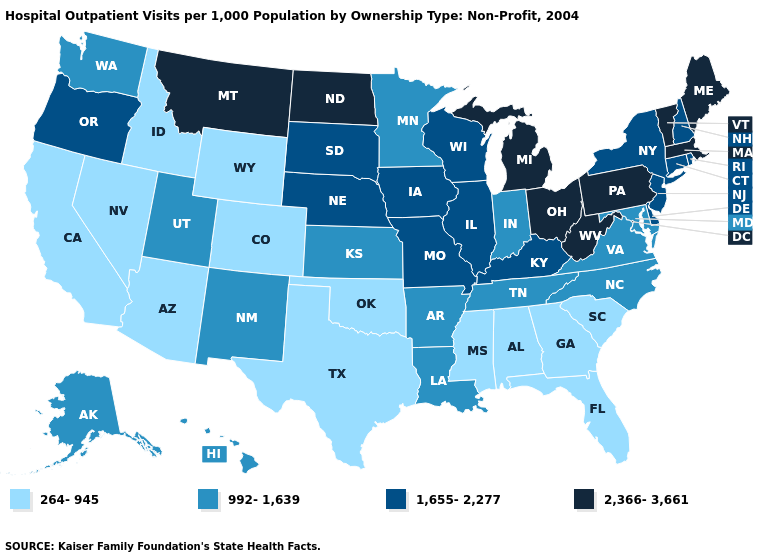Does the map have missing data?
Answer briefly. No. Which states have the highest value in the USA?
Concise answer only. Maine, Massachusetts, Michigan, Montana, North Dakota, Ohio, Pennsylvania, Vermont, West Virginia. Name the states that have a value in the range 2,366-3,661?
Concise answer only. Maine, Massachusetts, Michigan, Montana, North Dakota, Ohio, Pennsylvania, Vermont, West Virginia. Name the states that have a value in the range 2,366-3,661?
Short answer required. Maine, Massachusetts, Michigan, Montana, North Dakota, Ohio, Pennsylvania, Vermont, West Virginia. Name the states that have a value in the range 264-945?
Keep it brief. Alabama, Arizona, California, Colorado, Florida, Georgia, Idaho, Mississippi, Nevada, Oklahoma, South Carolina, Texas, Wyoming. What is the lowest value in states that border Connecticut?
Quick response, please. 1,655-2,277. What is the lowest value in states that border Pennsylvania?
Answer briefly. 992-1,639. What is the highest value in the South ?
Write a very short answer. 2,366-3,661. What is the highest value in the West ?
Write a very short answer. 2,366-3,661. What is the highest value in the MidWest ?
Give a very brief answer. 2,366-3,661. What is the value of Arizona?
Answer briefly. 264-945. What is the value of Alaska?
Write a very short answer. 992-1,639. Name the states that have a value in the range 1,655-2,277?
Be succinct. Connecticut, Delaware, Illinois, Iowa, Kentucky, Missouri, Nebraska, New Hampshire, New Jersey, New York, Oregon, Rhode Island, South Dakota, Wisconsin. Name the states that have a value in the range 1,655-2,277?
Answer briefly. Connecticut, Delaware, Illinois, Iowa, Kentucky, Missouri, Nebraska, New Hampshire, New Jersey, New York, Oregon, Rhode Island, South Dakota, Wisconsin. Among the states that border Kansas , which have the highest value?
Quick response, please. Missouri, Nebraska. 